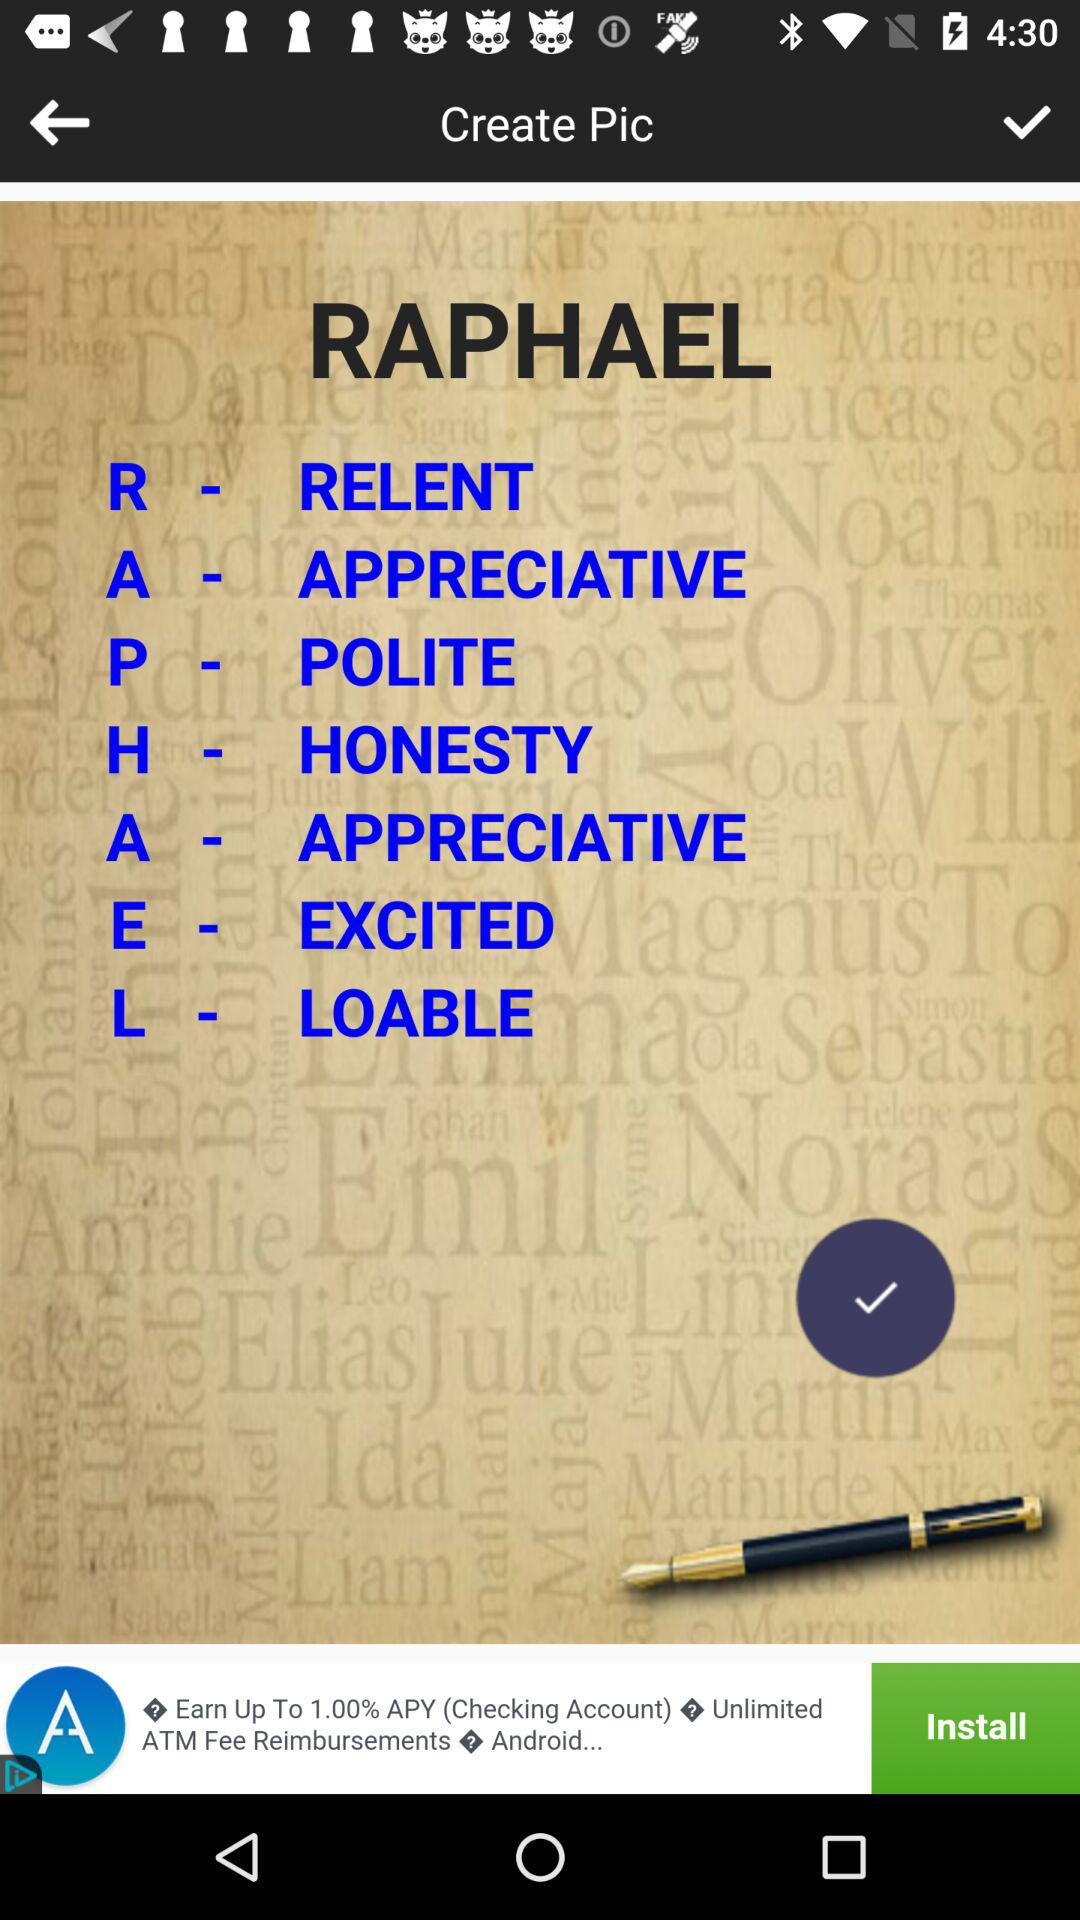What is the user name? The user name is Raphael. 